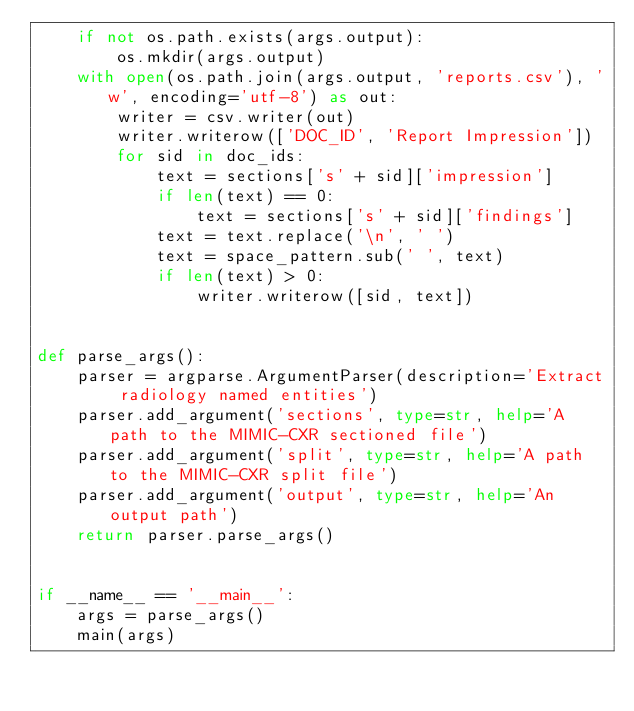Convert code to text. <code><loc_0><loc_0><loc_500><loc_500><_Python_>    if not os.path.exists(args.output):
        os.mkdir(args.output)
    with open(os.path.join(args.output, 'reports.csv'), 'w', encoding='utf-8') as out:
        writer = csv.writer(out)
        writer.writerow(['DOC_ID', 'Report Impression'])
        for sid in doc_ids:
            text = sections['s' + sid]['impression']
            if len(text) == 0:
                text = sections['s' + sid]['findings']
            text = text.replace('\n', ' ')
            text = space_pattern.sub(' ', text)
            if len(text) > 0:
                writer.writerow([sid, text])


def parse_args():
    parser = argparse.ArgumentParser(description='Extract radiology named entities')
    parser.add_argument('sections', type=str, help='A path to the MIMIC-CXR sectioned file')
    parser.add_argument('split', type=str, help='A path to the MIMIC-CXR split file')
    parser.add_argument('output', type=str, help='An output path')
    return parser.parse_args()


if __name__ == '__main__':
    args = parse_args()
    main(args)
</code> 